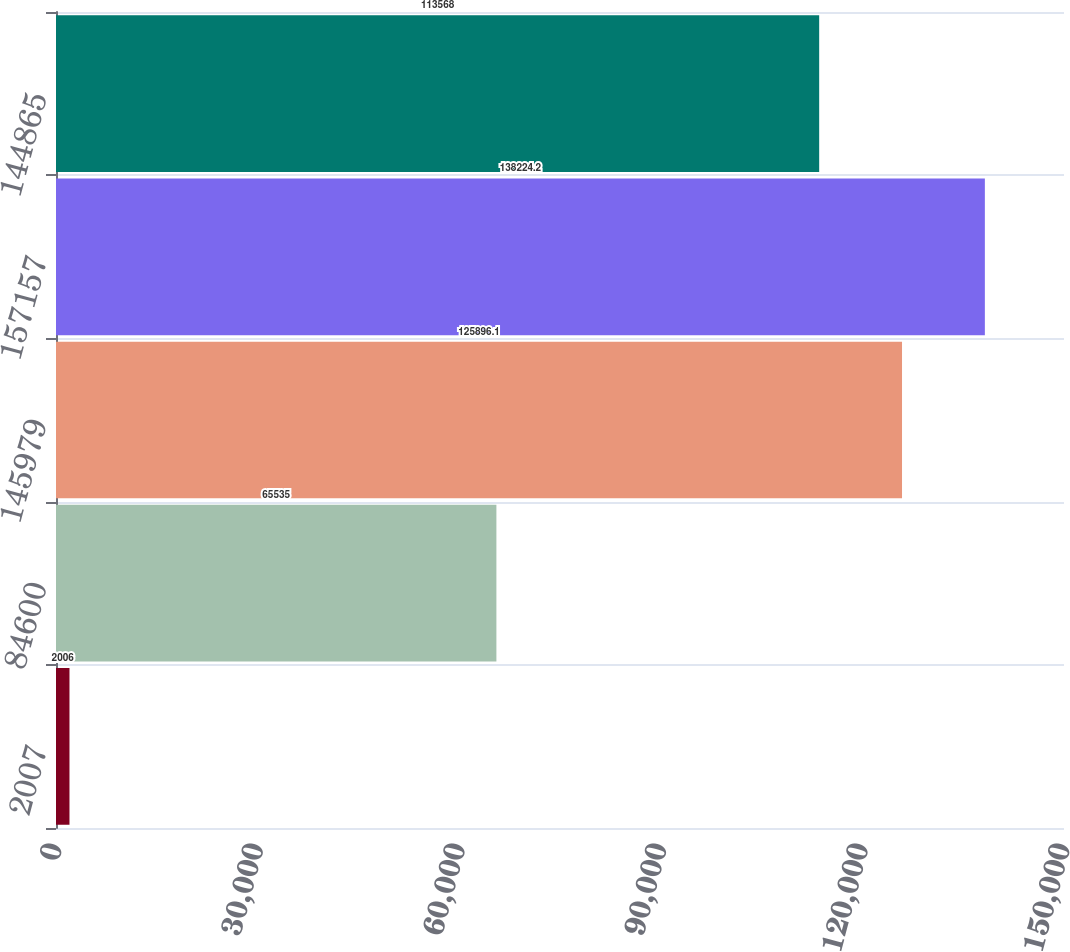<chart> <loc_0><loc_0><loc_500><loc_500><bar_chart><fcel>2007<fcel>84600<fcel>145979<fcel>157157<fcel>144865<nl><fcel>2006<fcel>65535<fcel>125896<fcel>138224<fcel>113568<nl></chart> 